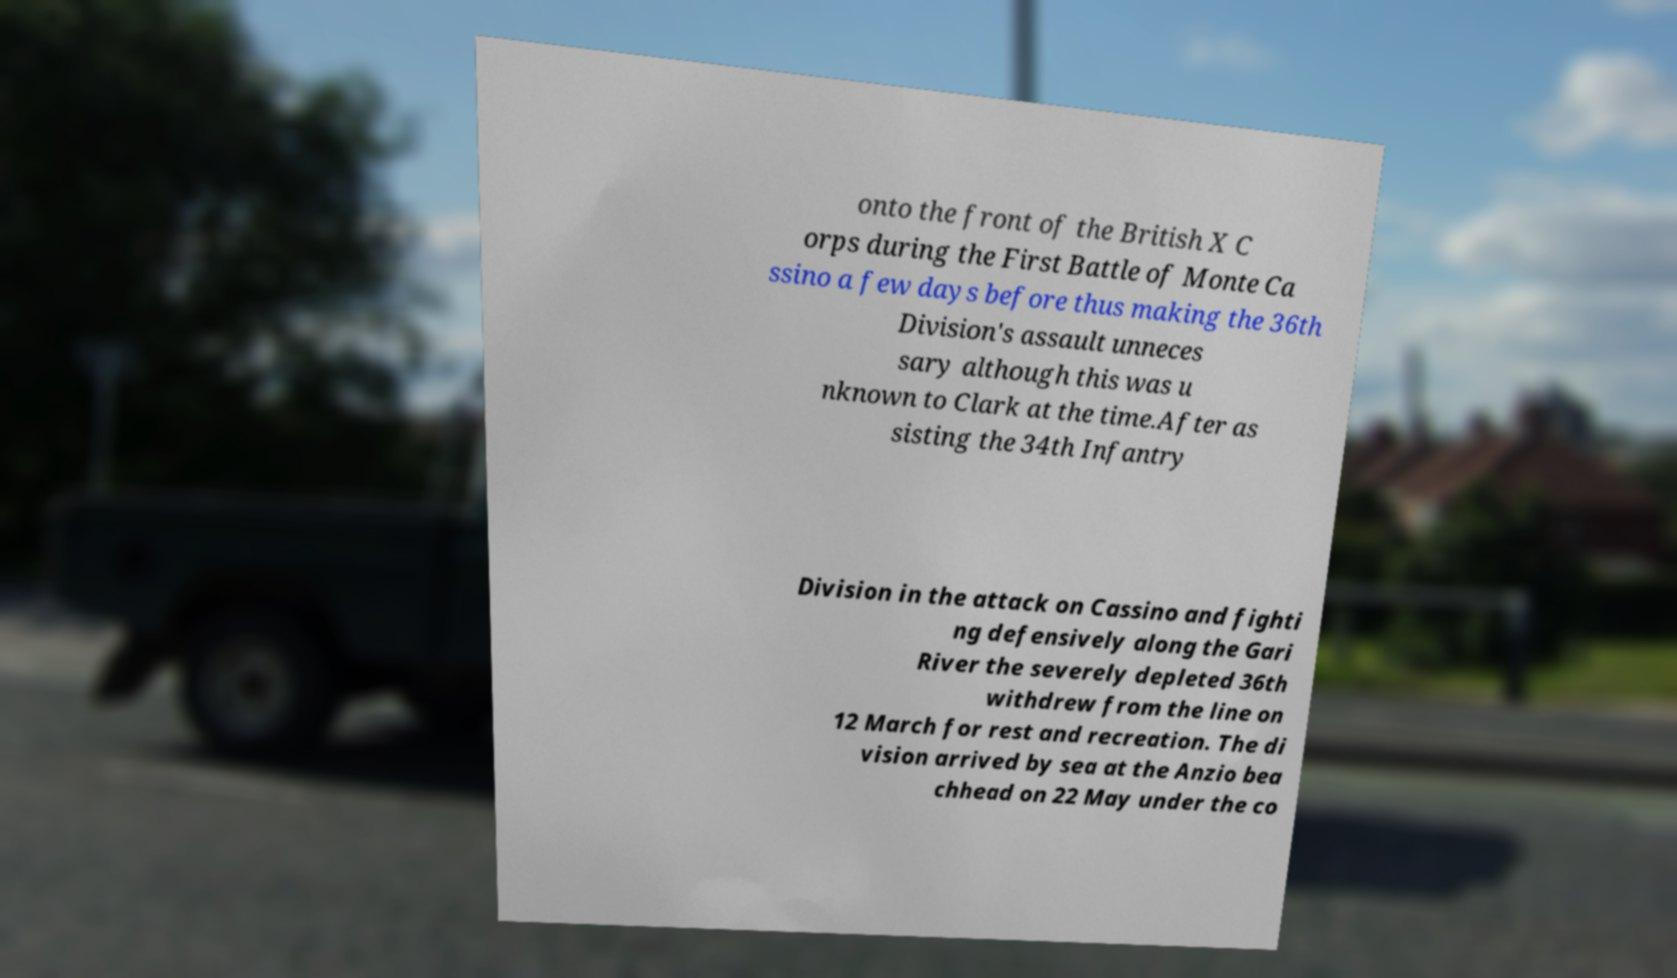Please identify and transcribe the text found in this image. onto the front of the British X C orps during the First Battle of Monte Ca ssino a few days before thus making the 36th Division's assault unneces sary although this was u nknown to Clark at the time.After as sisting the 34th Infantry Division in the attack on Cassino and fighti ng defensively along the Gari River the severely depleted 36th withdrew from the line on 12 March for rest and recreation. The di vision arrived by sea at the Anzio bea chhead on 22 May under the co 